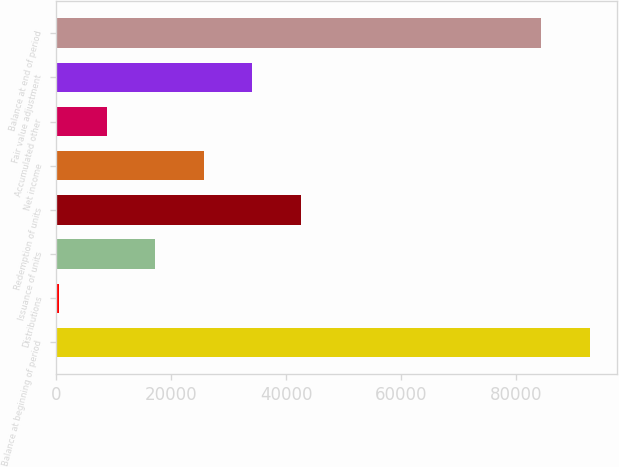Convert chart to OTSL. <chart><loc_0><loc_0><loc_500><loc_500><bar_chart><fcel>Balance at beginning of period<fcel>Distributions<fcel>Issuance of units<fcel>Redemption of units<fcel>Net income<fcel>Accumulated other<fcel>Fair value adjustment<fcel>Balance at end of period<nl><fcel>92748.7<fcel>511<fcel>17332.4<fcel>42564.5<fcel>25743.1<fcel>8921.7<fcel>34153.8<fcel>84338<nl></chart> 